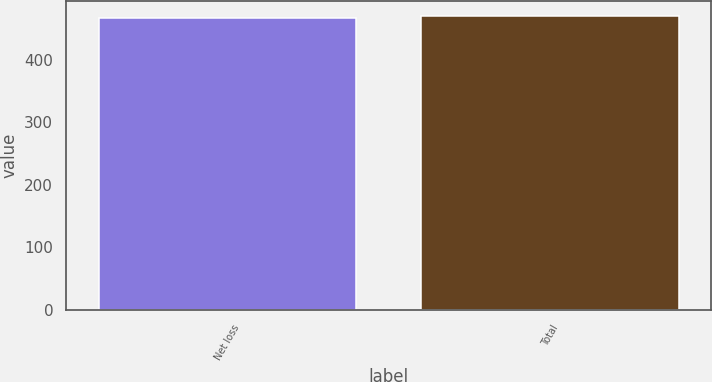Convert chart to OTSL. <chart><loc_0><loc_0><loc_500><loc_500><bar_chart><fcel>Net loss<fcel>Total<nl><fcel>467<fcel>470<nl></chart> 